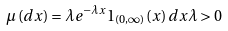<formula> <loc_0><loc_0><loc_500><loc_500>\mu \left ( d x \right ) = \lambda e ^ { - \lambda x } 1 _ { \left ( 0 , \infty \right ) } \left ( x \right ) d x \lambda > 0</formula> 